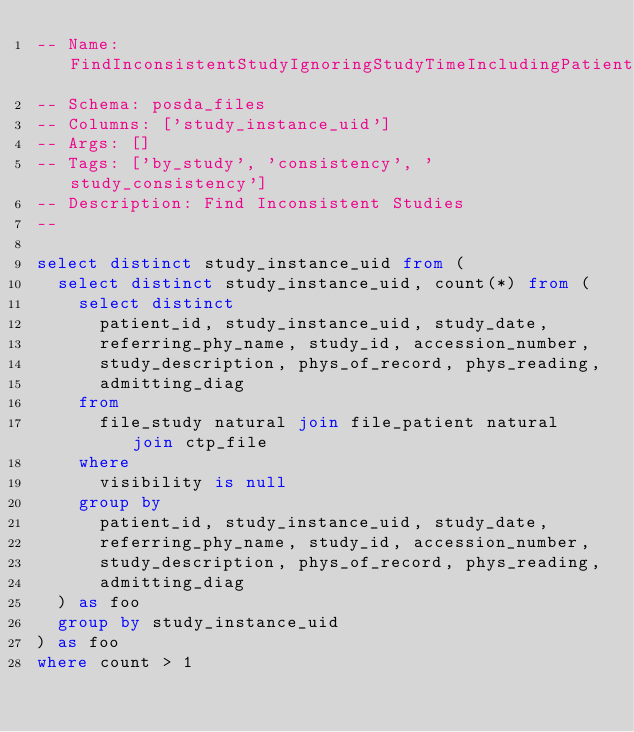<code> <loc_0><loc_0><loc_500><loc_500><_SQL_>-- Name: FindInconsistentStudyIgnoringStudyTimeIncludingPatientIdAll
-- Schema: posda_files
-- Columns: ['study_instance_uid']
-- Args: []
-- Tags: ['by_study', 'consistency', 'study_consistency']
-- Description: Find Inconsistent Studies
-- 

select distinct study_instance_uid from (
  select distinct study_instance_uid, count(*) from (
    select distinct
      patient_id, study_instance_uid, study_date,
      referring_phy_name, study_id, accession_number,
      study_description, phys_of_record, phys_reading,
      admitting_diag
    from
      file_study natural join file_patient natural join ctp_file
    where
      visibility is null
    group by
      patient_id, study_instance_uid, study_date,
      referring_phy_name, study_id, accession_number,
      study_description, phys_of_record, phys_reading,
      admitting_diag
  ) as foo
  group by study_instance_uid
) as foo
where count > 1
</code> 